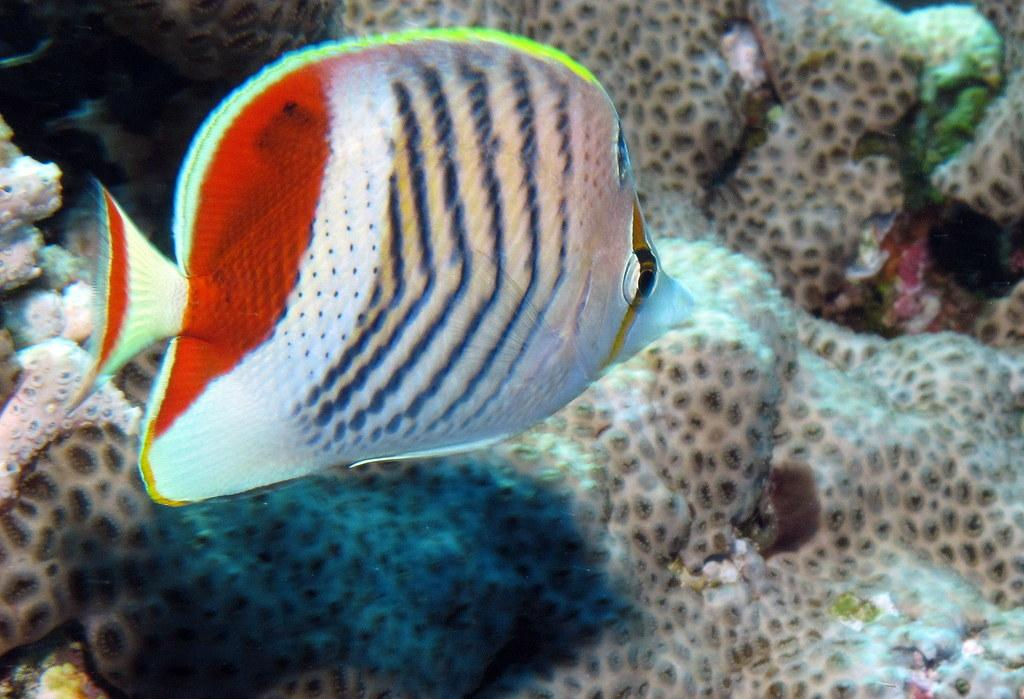What type of animal is present in the image? There is a fish in the image. What can be found in the same environment as the fish? There are corals in the image. Can you describe any other objects or features in the image? There are other unspecified objects in the image. What type of wound can be seen on the fish in the image? There is no wound visible on the fish in the image. What color is the blood coming from the wound on the fish in the image? There is no blood or wound present on the fish in the image. 